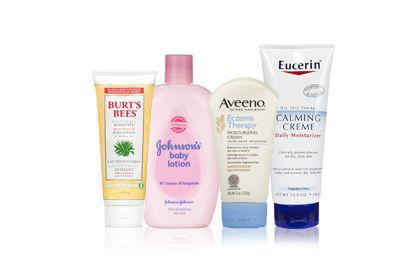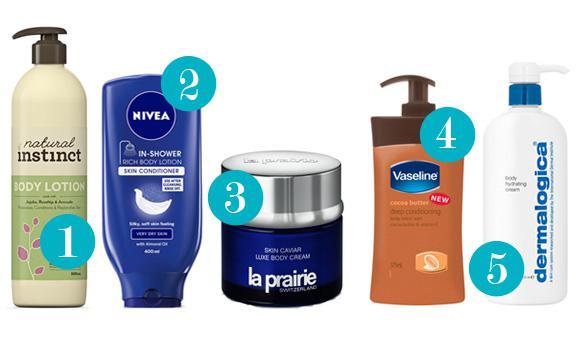The first image is the image on the left, the second image is the image on the right. Assess this claim about the two images: "In at least one image there are total of four different shaped bottles.". Correct or not? Answer yes or no. Yes. The first image is the image on the left, the second image is the image on the right. Examine the images to the left and right. Is the description "There are more items in the right image than in the left image." accurate? Answer yes or no. Yes. 